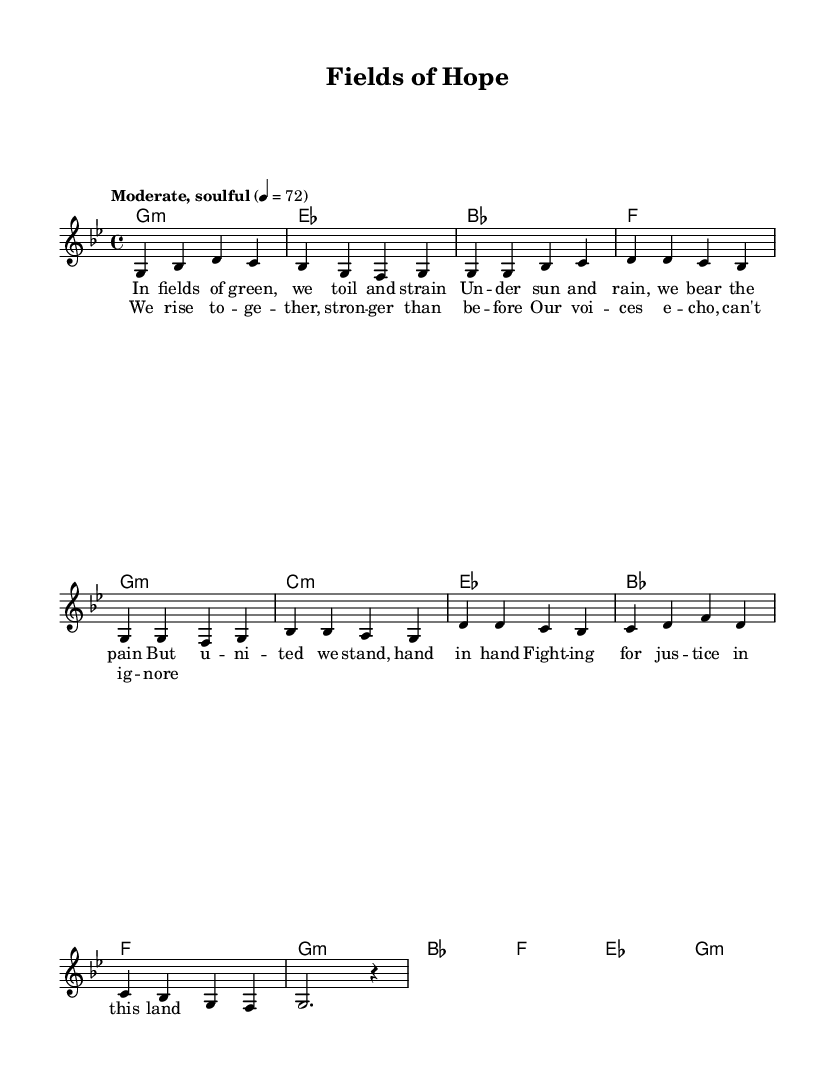What is the key signature of this music? The key signature is G minor, which has two flats (B flat and E flat). This can be identified by the key indication at the beginning of the staff.
Answer: G minor What is the time signature of this music? The time signature is 4/4, meaning there are four beats per measure. This is shown right after the key signature at the beginning of the score.
Answer: 4/4 What is the tempo marking for this piece? The tempo marking is "Moderate, soulful," indicating the character and speed for performing the music. This is specified above the staff at the beginning of the score.
Answer: Moderate, soulful How many measures are in the verse section? The verse consists of 8 measures, which can be counted by checking the melody and chord layout in the score. Each line represents 4 measures, and there are 2 lines of verses.
Answer: 8 measures Which harmony chord is played in the first measure? The harmony chord in the first measure is G minor, indicated by the chord symbol above the staff at the beginning of the score.
Answer: G minor What lyrical theme is presented in the chorus? The lyrical theme of the chorus focuses on unity and strength, capturing the essence of collective action for justice. This can be inferred from the lyrics provided in the chorus section in the score.
Answer: Unity and strength What is the last note in the melody of the chorus? The last note in the melody of the chorus is a quarter note G, as shown in the melody line where it ends on a G note followed by a rest.
Answer: G 